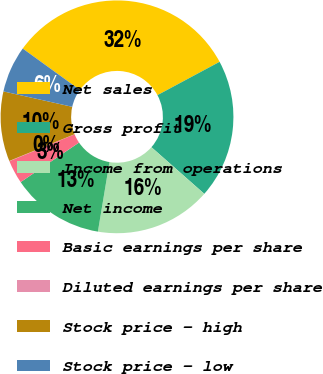Convert chart. <chart><loc_0><loc_0><loc_500><loc_500><pie_chart><fcel>Net sales<fcel>Gross profit<fcel>Income from operations<fcel>Net income<fcel>Basic earnings per share<fcel>Diluted earnings per share<fcel>Stock price - high<fcel>Stock price - low<nl><fcel>32.2%<fcel>19.34%<fcel>16.12%<fcel>12.9%<fcel>3.25%<fcel>0.04%<fcel>9.69%<fcel>6.47%<nl></chart> 